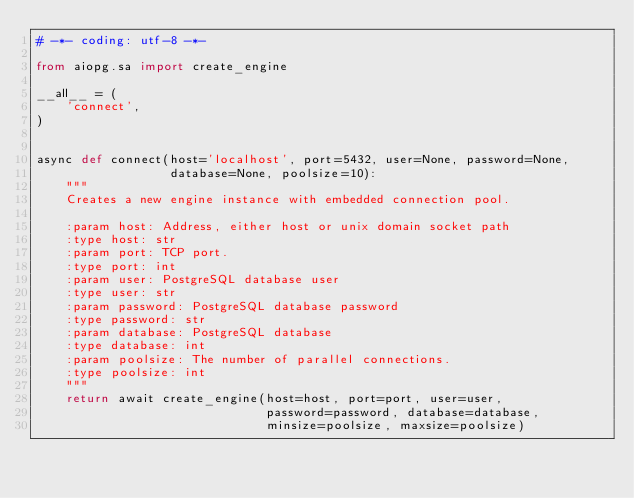<code> <loc_0><loc_0><loc_500><loc_500><_Python_># -*- coding: utf-8 -*-

from aiopg.sa import create_engine

__all__ = (
    'connect',
)


async def connect(host='localhost', port=5432, user=None, password=None,
                  database=None, poolsize=10):
    """
    Creates a new engine instance with embedded connection pool.

    :param host: Address, either host or unix domain socket path
    :type host: str
    :param port: TCP port.
    :type port: int
    :param user: PostgreSQL database user
    :type user: str
    :param password: PostgreSQL database password
    :type password: str
    :param database: PostgreSQL database
    :type database: int
    :param poolsize: The number of parallel connections.
    :type poolsize: int
    """
    return await create_engine(host=host, port=port, user=user,
                               password=password, database=database,
                               minsize=poolsize, maxsize=poolsize)
</code> 